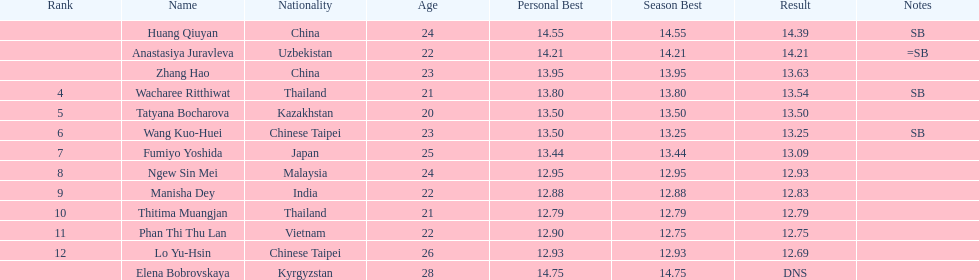What nationality was the woman who won first place? China. 